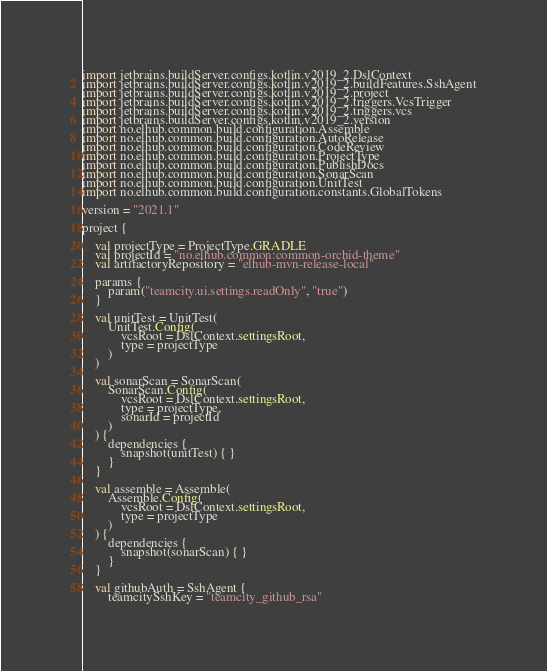<code> <loc_0><loc_0><loc_500><loc_500><_Kotlin_>import jetbrains.buildServer.configs.kotlin.v2019_2.DslContext
import jetbrains.buildServer.configs.kotlin.v2019_2.buildFeatures.SshAgent
import jetbrains.buildServer.configs.kotlin.v2019_2.project
import jetbrains.buildServer.configs.kotlin.v2019_2.triggers.VcsTrigger
import jetbrains.buildServer.configs.kotlin.v2019_2.triggers.vcs
import jetbrains.buildServer.configs.kotlin.v2019_2.version
import no.elhub.common.build.configuration.Assemble
import no.elhub.common.build.configuration.AutoRelease
import no.elhub.common.build.configuration.CodeReview
import no.elhub.common.build.configuration.ProjectType
import no.elhub.common.build.configuration.PublishDocs
import no.elhub.common.build.configuration.SonarScan
import no.elhub.common.build.configuration.UnitTest
import no.elhub.common.build.configuration.constants.GlobalTokens

version = "2021.1"

project {

    val projectType = ProjectType.GRADLE
    val projectId = "no.elhub.common:common-orchid-theme"
    val artifactoryRepository = "elhub-mvn-release-local"

    params {
        param("teamcity.ui.settings.readOnly", "true")
    }

    val unitTest = UnitTest(
        UnitTest.Config(
            vcsRoot = DslContext.settingsRoot,
            type = projectType
        )
    )

    val sonarScan = SonarScan(
        SonarScan.Config(
            vcsRoot = DslContext.settingsRoot,
            type = projectType,
            sonarId = projectId
        )
    ) {
        dependencies {
            snapshot(unitTest) { }
        }
    }

    val assemble = Assemble(
        Assemble.Config(
            vcsRoot = DslContext.settingsRoot,
            type = projectType
        )
    ) {
        dependencies {
            snapshot(sonarScan) { }
        }
    }

    val githubAuth = SshAgent {
        teamcitySshKey = "teamcity_github_rsa"</code> 